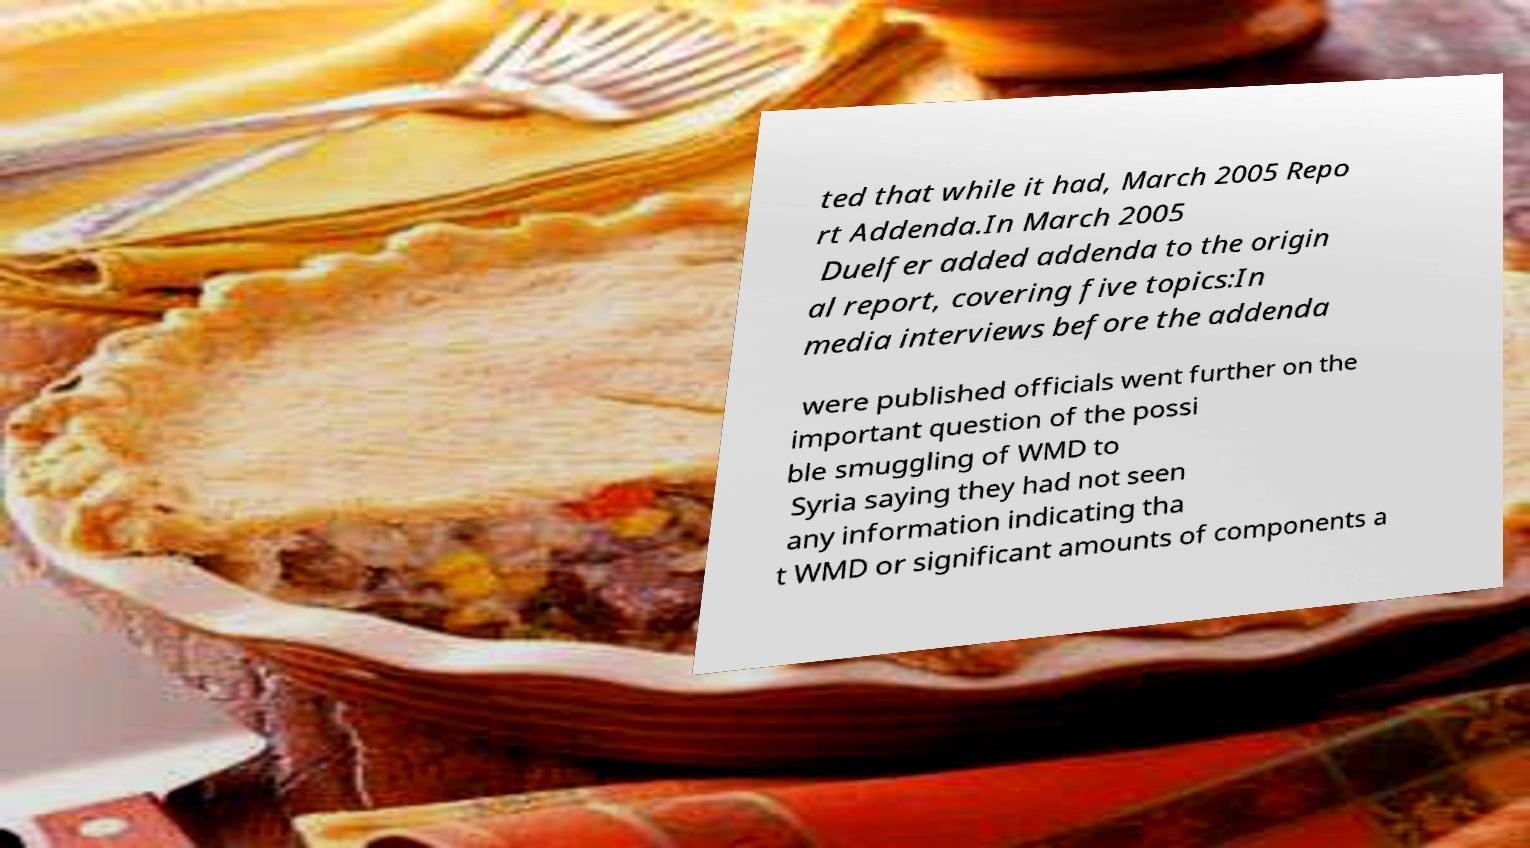What messages or text are displayed in this image? I need them in a readable, typed format. ted that while it had, March 2005 Repo rt Addenda.In March 2005 Duelfer added addenda to the origin al report, covering five topics:In media interviews before the addenda were published officials went further on the important question of the possi ble smuggling of WMD to Syria saying they had not seen any information indicating tha t WMD or significant amounts of components a 